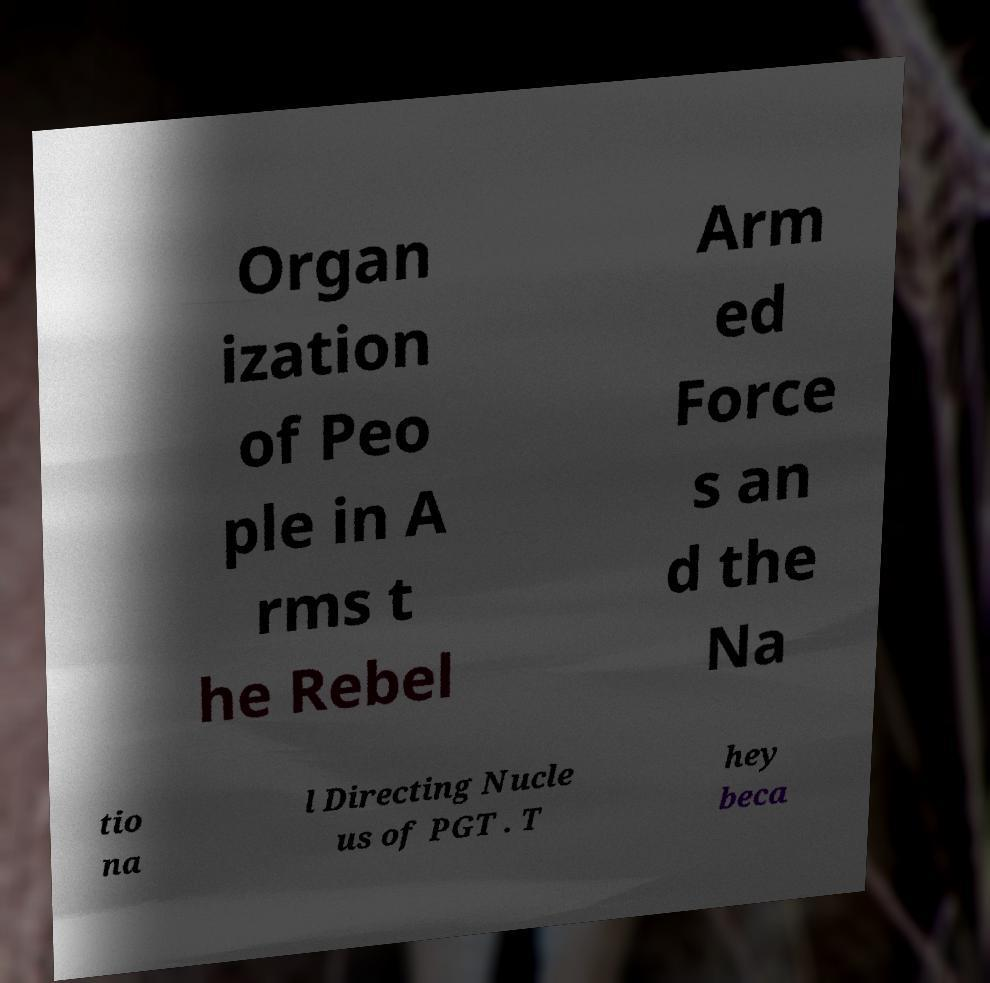Can you accurately transcribe the text from the provided image for me? Organ ization of Peo ple in A rms t he Rebel Arm ed Force s an d the Na tio na l Directing Nucle us of PGT . T hey beca 